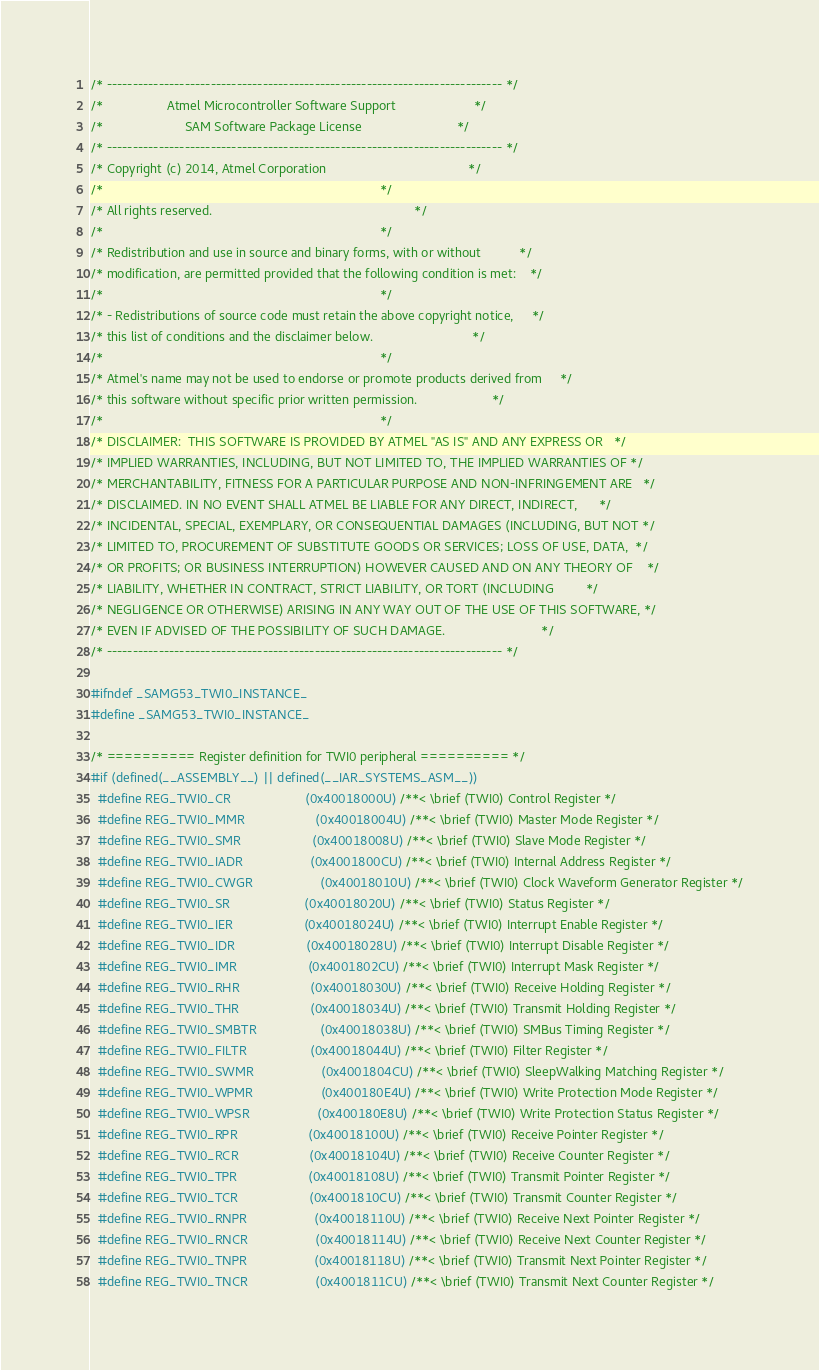<code> <loc_0><loc_0><loc_500><loc_500><_C_>/* ---------------------------------------------------------------------------- */
/*                  Atmel Microcontroller Software Support                      */
/*                       SAM Software Package License                           */
/* ---------------------------------------------------------------------------- */
/* Copyright (c) 2014, Atmel Corporation                                        */
/*                                                                              */
/* All rights reserved.                                                         */
/*                                                                              */
/* Redistribution and use in source and binary forms, with or without           */
/* modification, are permitted provided that the following condition is met:    */
/*                                                                              */
/* - Redistributions of source code must retain the above copyright notice,     */
/* this list of conditions and the disclaimer below.                            */
/*                                                                              */
/* Atmel's name may not be used to endorse or promote products derived from     */
/* this software without specific prior written permission.                     */
/*                                                                              */
/* DISCLAIMER:  THIS SOFTWARE IS PROVIDED BY ATMEL "AS IS" AND ANY EXPRESS OR   */
/* IMPLIED WARRANTIES, INCLUDING, BUT NOT LIMITED TO, THE IMPLIED WARRANTIES OF */
/* MERCHANTABILITY, FITNESS FOR A PARTICULAR PURPOSE AND NON-INFRINGEMENT ARE   */
/* DISCLAIMED. IN NO EVENT SHALL ATMEL BE LIABLE FOR ANY DIRECT, INDIRECT,      */
/* INCIDENTAL, SPECIAL, EXEMPLARY, OR CONSEQUENTIAL DAMAGES (INCLUDING, BUT NOT */
/* LIMITED TO, PROCUREMENT OF SUBSTITUTE GOODS OR SERVICES; LOSS OF USE, DATA,  */
/* OR PROFITS; OR BUSINESS INTERRUPTION) HOWEVER CAUSED AND ON ANY THEORY OF    */
/* LIABILITY, WHETHER IN CONTRACT, STRICT LIABILITY, OR TORT (INCLUDING         */
/* NEGLIGENCE OR OTHERWISE) ARISING IN ANY WAY OUT OF THE USE OF THIS SOFTWARE, */
/* EVEN IF ADVISED OF THE POSSIBILITY OF SUCH DAMAGE.                           */
/* ---------------------------------------------------------------------------- */

#ifndef _SAMG53_TWI0_INSTANCE_
#define _SAMG53_TWI0_INSTANCE_

/* ========== Register definition for TWI0 peripheral ========== */
#if (defined(__ASSEMBLY__) || defined(__IAR_SYSTEMS_ASM__))
  #define REG_TWI0_CR                     (0x40018000U) /**< \brief (TWI0) Control Register */
  #define REG_TWI0_MMR                    (0x40018004U) /**< \brief (TWI0) Master Mode Register */
  #define REG_TWI0_SMR                    (0x40018008U) /**< \brief (TWI0) Slave Mode Register */
  #define REG_TWI0_IADR                   (0x4001800CU) /**< \brief (TWI0) Internal Address Register */
  #define REG_TWI0_CWGR                   (0x40018010U) /**< \brief (TWI0) Clock Waveform Generator Register */
  #define REG_TWI0_SR                     (0x40018020U) /**< \brief (TWI0) Status Register */
  #define REG_TWI0_IER                    (0x40018024U) /**< \brief (TWI0) Interrupt Enable Register */
  #define REG_TWI0_IDR                    (0x40018028U) /**< \brief (TWI0) Interrupt Disable Register */
  #define REG_TWI0_IMR                    (0x4001802CU) /**< \brief (TWI0) Interrupt Mask Register */
  #define REG_TWI0_RHR                    (0x40018030U) /**< \brief (TWI0) Receive Holding Register */
  #define REG_TWI0_THR                    (0x40018034U) /**< \brief (TWI0) Transmit Holding Register */
  #define REG_TWI0_SMBTR                  (0x40018038U) /**< \brief (TWI0) SMBus Timing Register */
  #define REG_TWI0_FILTR                  (0x40018044U) /**< \brief (TWI0) Filter Register */
  #define REG_TWI0_SWMR                   (0x4001804CU) /**< \brief (TWI0) SleepWalking Matching Register */
  #define REG_TWI0_WPMR                   (0x400180E4U) /**< \brief (TWI0) Write Protection Mode Register */
  #define REG_TWI0_WPSR                   (0x400180E8U) /**< \brief (TWI0) Write Protection Status Register */
  #define REG_TWI0_RPR                    (0x40018100U) /**< \brief (TWI0) Receive Pointer Register */
  #define REG_TWI0_RCR                    (0x40018104U) /**< \brief (TWI0) Receive Counter Register */
  #define REG_TWI0_TPR                    (0x40018108U) /**< \brief (TWI0) Transmit Pointer Register */
  #define REG_TWI0_TCR                    (0x4001810CU) /**< \brief (TWI0) Transmit Counter Register */
  #define REG_TWI0_RNPR                   (0x40018110U) /**< \brief (TWI0) Receive Next Pointer Register */
  #define REG_TWI0_RNCR                   (0x40018114U) /**< \brief (TWI0) Receive Next Counter Register */
  #define REG_TWI0_TNPR                   (0x40018118U) /**< \brief (TWI0) Transmit Next Pointer Register */
  #define REG_TWI0_TNCR                   (0x4001811CU) /**< \brief (TWI0) Transmit Next Counter Register */</code> 